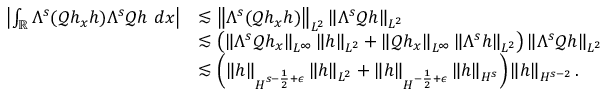<formula> <loc_0><loc_0><loc_500><loc_500>\begin{array} { r l } { \left | \int _ { \mathbb { R } } \Lambda ^ { s } ( \ m a t h s c r { Q } h _ { x } h ) \Lambda ^ { s } \ m a t h s c r { Q } h \ d x \right | } & { \lesssim \left \| \Lambda ^ { s } ( \ m a t h s c r { Q } h _ { x } h ) \right \| _ { L ^ { 2 } } \left \| \Lambda ^ { s } \ m a t h s c r { Q } h \right \| _ { L ^ { 2 } } } \\ & { \lesssim \left ( \left \| \Lambda ^ { s } \ m a t h s c r { Q } h _ { x } \right \| _ { L ^ { \infty } } \left \| h \right \| _ { L ^ { 2 } } + \left \| \ m a t h s c r { Q } h _ { x } \right \| _ { L ^ { \infty } } \left \| \Lambda ^ { s } h \right \| _ { L ^ { 2 } } \right ) \left \| \Lambda ^ { s } \ m a t h s c r { Q } h \right \| _ { L ^ { 2 } } } \\ & { \lesssim \left ( \left \| h \right \| _ { H ^ { s - \frac { 1 } { 2 } + \epsilon } } \left \| h \right \| _ { L ^ { 2 } } + \left \| h \right \| _ { H ^ { - \frac { 1 } { 2 } + \epsilon } } \left \| h \right \| _ { H ^ { s } } \right ) \left \| h \right \| _ { H ^ { s - 2 } } . } \end{array}</formula> 